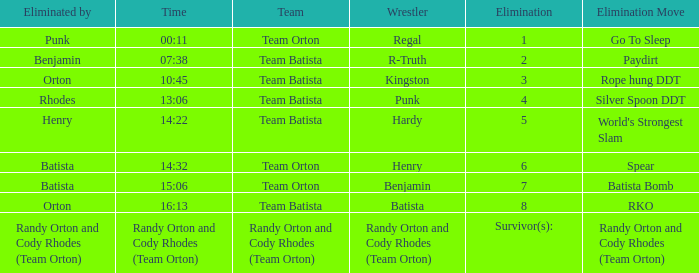Which Wrestler plays for Team Batista which was Elimated by Orton on Elimination 8? Batista. Parse the table in full. {'header': ['Eliminated by', 'Time', 'Team', 'Wrestler', 'Elimination', 'Elimination Move'], 'rows': [['Punk', '00:11', 'Team Orton', 'Regal', '1', 'Go To Sleep'], ['Benjamin', '07:38', 'Team Batista', 'R-Truth', '2', 'Paydirt'], ['Orton', '10:45', 'Team Batista', 'Kingston', '3', 'Rope hung DDT'], ['Rhodes', '13:06', 'Team Batista', 'Punk', '4', 'Silver Spoon DDT'], ['Henry', '14:22', 'Team Batista', 'Hardy', '5', "World's Strongest Slam"], ['Batista', '14:32', 'Team Orton', 'Henry', '6', 'Spear'], ['Batista', '15:06', 'Team Orton', 'Benjamin', '7', 'Batista Bomb'], ['Orton', '16:13', 'Team Batista', 'Batista', '8', 'RKO'], ['Randy Orton and Cody Rhodes (Team Orton)', 'Randy Orton and Cody Rhodes (Team Orton)', 'Randy Orton and Cody Rhodes (Team Orton)', 'Randy Orton and Cody Rhodes (Team Orton)', 'Survivor(s):', 'Randy Orton and Cody Rhodes (Team Orton)']]} 